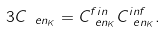<formula> <loc_0><loc_0><loc_500><loc_500>3 C _ { \ e n _ { K } } & = C ^ { f i n } _ { \ e n _ { K } } C ^ { i n f } _ { \ e n _ { K } } .</formula> 